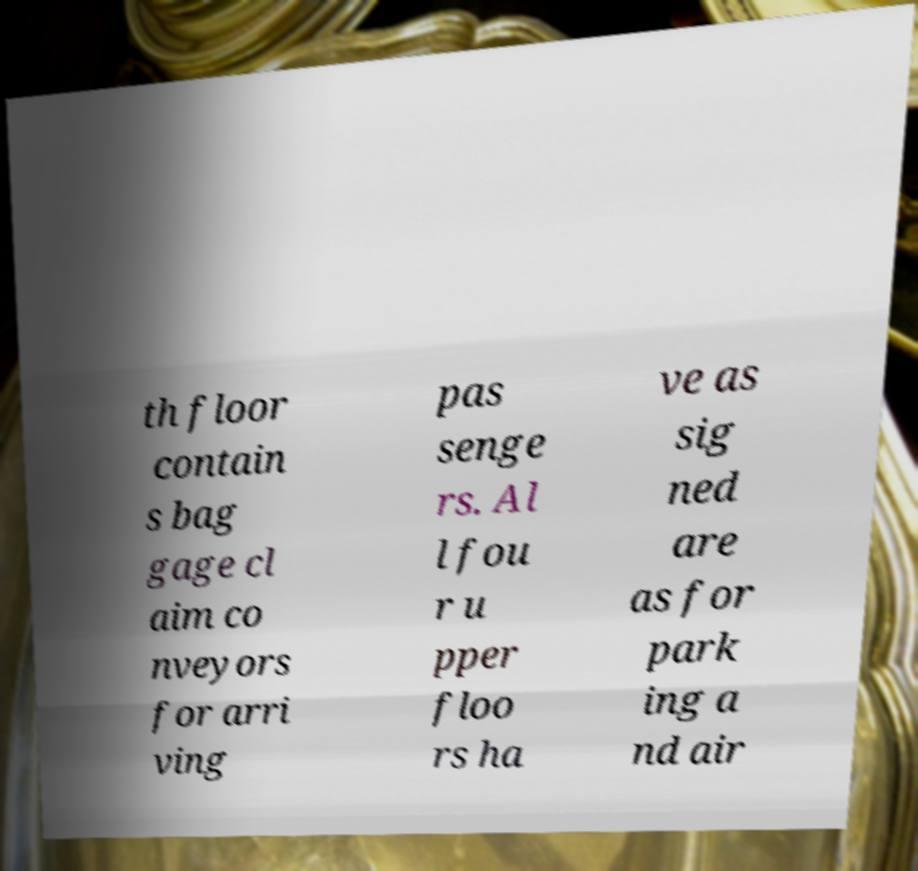I need the written content from this picture converted into text. Can you do that? th floor contain s bag gage cl aim co nveyors for arri ving pas senge rs. Al l fou r u pper floo rs ha ve as sig ned are as for park ing a nd air 